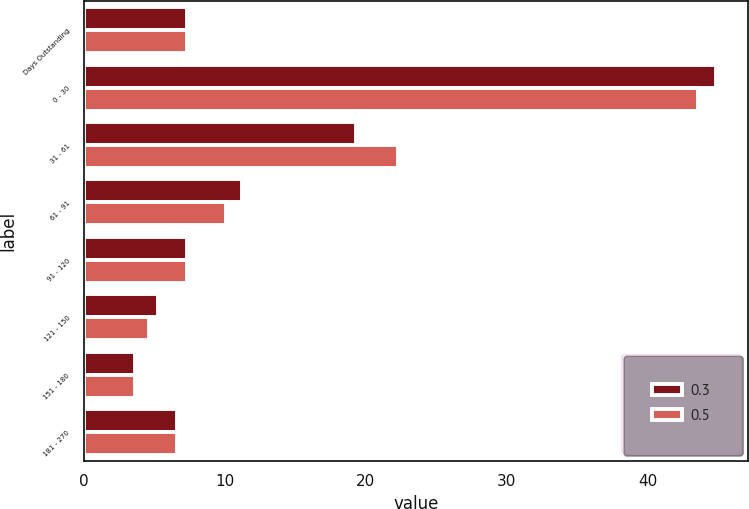<chart> <loc_0><loc_0><loc_500><loc_500><stacked_bar_chart><ecel><fcel>Days Outstanding<fcel>0 - 30<fcel>31 - 61<fcel>61 - 91<fcel>91 - 120<fcel>121 - 150<fcel>151 - 180<fcel>181 - 270<nl><fcel>0.3<fcel>7.3<fcel>44.9<fcel>19.3<fcel>11.2<fcel>7.3<fcel>5.2<fcel>3.6<fcel>6.6<nl><fcel>0.5<fcel>7.3<fcel>43.6<fcel>22.3<fcel>10.1<fcel>7.3<fcel>4.6<fcel>3.6<fcel>6.6<nl></chart> 